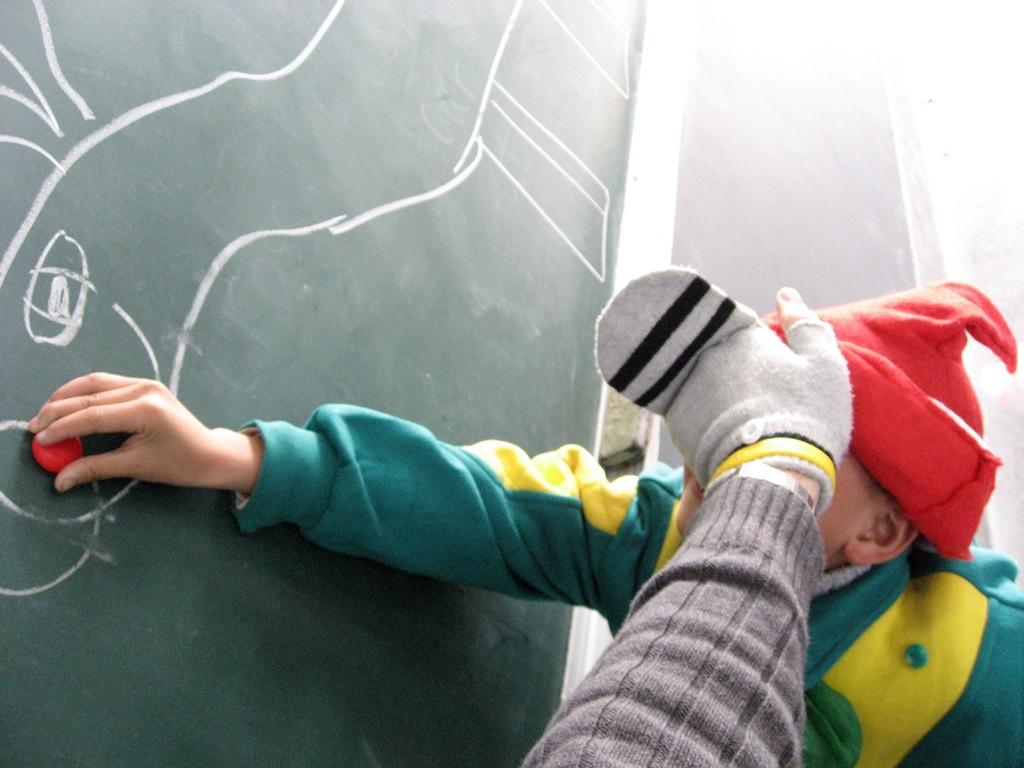Who is present in the image besides the boy? There is a person's hand in the image. What is the person's hand doing to the boy? The person's hand is closing the boy's eyes. What activity are the boy and the person engaged in? Both the boy and the person are playing in the image. What can be seen in the background of the image? There is a board in the background of the image. What type of slope can be seen in the image? There is no slope present in the image; it features a boy and a person's hand playing and a board in the background. 